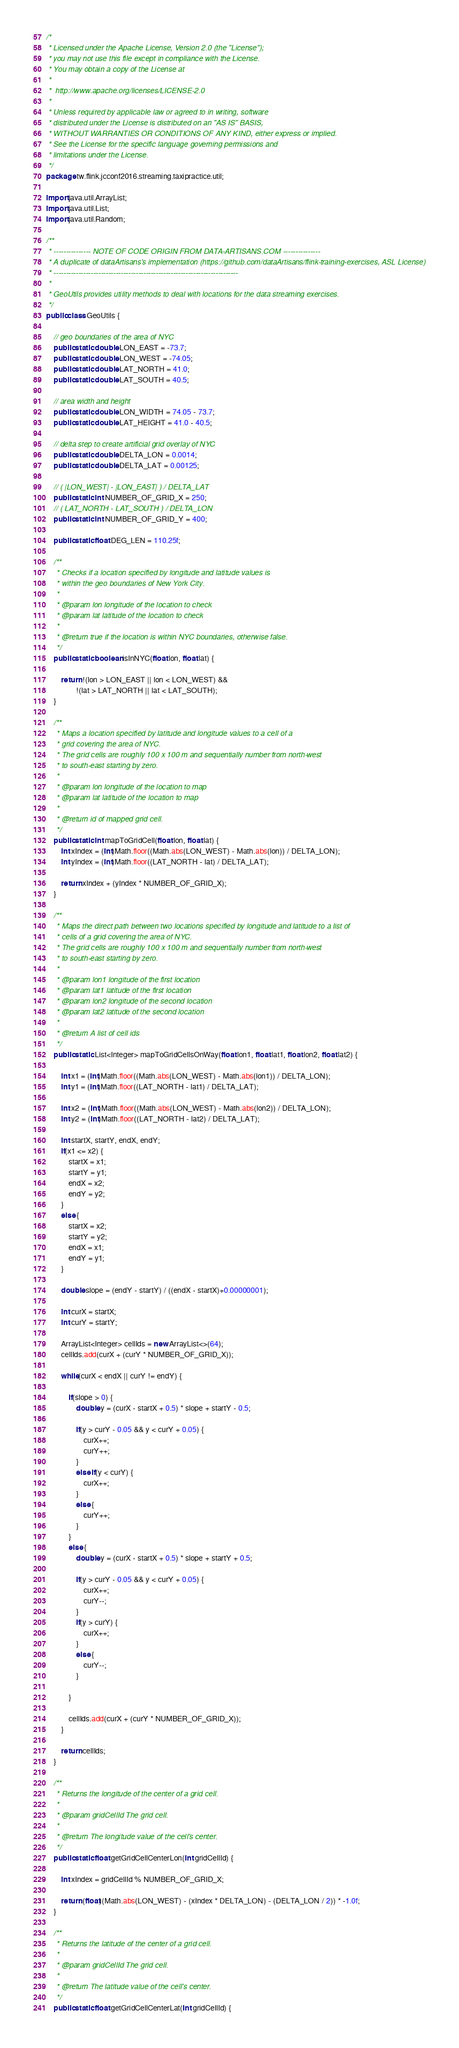Convert code to text. <code><loc_0><loc_0><loc_500><loc_500><_Java_>/*
 * Licensed under the Apache License, Version 2.0 (the "License");
 * you may not use this file except in compliance with the License.
 * You may obtain a copy of the License at
 *
 *  http://www.apache.org/licenses/LICENSE-2.0
 *
 * Unless required by applicable law or agreed to in writing, software
 * distributed under the License is distributed on an "AS IS" BASIS,
 * WITHOUT WARRANTIES OR CONDITIONS OF ANY KIND, either express or implied.
 * See the License for the specific language governing permissions and
 * limitations under the License.
 */
package tw.flink.jcconf2016.streaming.taxipractice.util;

import java.util.ArrayList;
import java.util.List;
import java.util.Random;

/**
 * --------------- NOTE OF CODE ORIGIN FROM DATA-ARTISANS.COM ---------------
 * A duplicate of dataArtisans's implementation (https://github.com/dataArtisans/flink-training-exercises, ASL License)
 * --------------------------------------------------------------------------
 *
 * GeoUtils provides utility methods to deal with locations for the data streaming exercises.
 */
public class GeoUtils {

	// geo boundaries of the area of NYC
	public static double LON_EAST = -73.7;
	public static double LON_WEST = -74.05;
	public static double LAT_NORTH = 41.0;
	public static double LAT_SOUTH = 40.5;

	// area width and height
	public static double LON_WIDTH = 74.05 - 73.7;
	public static double LAT_HEIGHT = 41.0 - 40.5;

	// delta step to create artificial grid overlay of NYC
	public static double DELTA_LON = 0.0014;
	public static double DELTA_LAT = 0.00125;

	// ( |LON_WEST| - |LON_EAST| ) / DELTA_LAT
	public static int NUMBER_OF_GRID_X = 250;
	// ( LAT_NORTH - LAT_SOUTH ) / DELTA_LON
	public static int NUMBER_OF_GRID_Y = 400;

	public static float DEG_LEN = 110.25f;

	/**
	 * Checks if a location specified by longitude and latitude values is
	 * within the geo boundaries of New York City.
	 *
	 * @param lon longitude of the location to check
	 * @param lat latitude of the location to check
	 *
	 * @return true if the location is within NYC boundaries, otherwise false.
	 */
	public static boolean isInNYC(float lon, float lat) {

		return !(lon > LON_EAST || lon < LON_WEST) &&
				!(lat > LAT_NORTH || lat < LAT_SOUTH);
	}

	/**
	 * Maps a location specified by latitude and longitude values to a cell of a
	 * grid covering the area of NYC.
	 * The grid cells are roughly 100 x 100 m and sequentially number from north-west
	 * to south-east starting by zero.
	 *
	 * @param lon longitude of the location to map
	 * @param lat latitude of the location to map
	 *
	 * @return id of mapped grid cell.
	 */
	public static int mapToGridCell(float lon, float lat) {
		int xIndex = (int)Math.floor((Math.abs(LON_WEST) - Math.abs(lon)) / DELTA_LON);
		int yIndex = (int)Math.floor((LAT_NORTH - lat) / DELTA_LAT);

		return xIndex + (yIndex * NUMBER_OF_GRID_X);
	}

	/**
	 * Maps the direct path between two locations specified by longitude and latitude to a list of
	 * cells of a grid covering the area of NYC.
	 * The grid cells are roughly 100 x 100 m and sequentially number from north-west
	 * to south-east starting by zero.
	 *
	 * @param lon1 longitude of the first location
	 * @param lat1 latitude of the first location
	 * @param lon2 longitude of the second location
	 * @param lat2 latitude of the second location
	 *
	 * @return A list of cell ids
	 */
	public static List<Integer> mapToGridCellsOnWay(float lon1, float lat1, float lon2, float lat2) {

		int x1 = (int)Math.floor((Math.abs(LON_WEST) - Math.abs(lon1)) / DELTA_LON);
		int y1 = (int)Math.floor((LAT_NORTH - lat1) / DELTA_LAT);

		int x2 = (int)Math.floor((Math.abs(LON_WEST) - Math.abs(lon2)) / DELTA_LON);
		int y2 = (int)Math.floor((LAT_NORTH - lat2) / DELTA_LAT);

		int startX, startY, endX, endY;
		if(x1 <= x2) {
			startX = x1;
			startY = y1;
			endX = x2;
			endY = y2;
		}
		else {
			startX = x2;
			startY = y2;
			endX = x1;
			endY = y1;
		}

		double slope = (endY - startY) / ((endX - startX)+0.00000001);

		int curX = startX;
		int curY = startY;

		ArrayList<Integer> cellIds = new ArrayList<>(64);
		cellIds.add(curX + (curY * NUMBER_OF_GRID_X));

		while(curX < endX || curY != endY) {

			if(slope > 0) {
				double y = (curX - startX + 0.5) * slope + startY - 0.5;

				if(y > curY - 0.05 && y < curY + 0.05) {
					curX++;
					curY++;
				}
				else if(y < curY) {
					curX++;
				}
				else {
					curY++;
				}
			}
			else {
				double y = (curX - startX + 0.5) * slope + startY + 0.5;

				if(y > curY - 0.05 && y < curY + 0.05) {
					curX++;
					curY--;
				}
				if(y > curY) {
					curX++;
				}
				else {
					curY--;
				}

			}

			cellIds.add(curX + (curY * NUMBER_OF_GRID_X));
		}

		return cellIds;
	}

	/**
	 * Returns the longitude of the center of a grid cell.
	 *
	 * @param gridCellId The grid cell.
	 *
	 * @return The longitude value of the cell's center.
	 */
	public static float getGridCellCenterLon(int gridCellId) {

		int xIndex = gridCellId % NUMBER_OF_GRID_X;

		return (float)(Math.abs(LON_WEST) - (xIndex * DELTA_LON) - (DELTA_LON / 2)) * -1.0f;
	}

	/**
	 * Returns the latitude of the center of a grid cell.
	 *
	 * @param gridCellId The grid cell.
	 *
	 * @return The latitude value of the cell's center.
	 */
	public static float getGridCellCenterLat(int gridCellId) {
</code> 